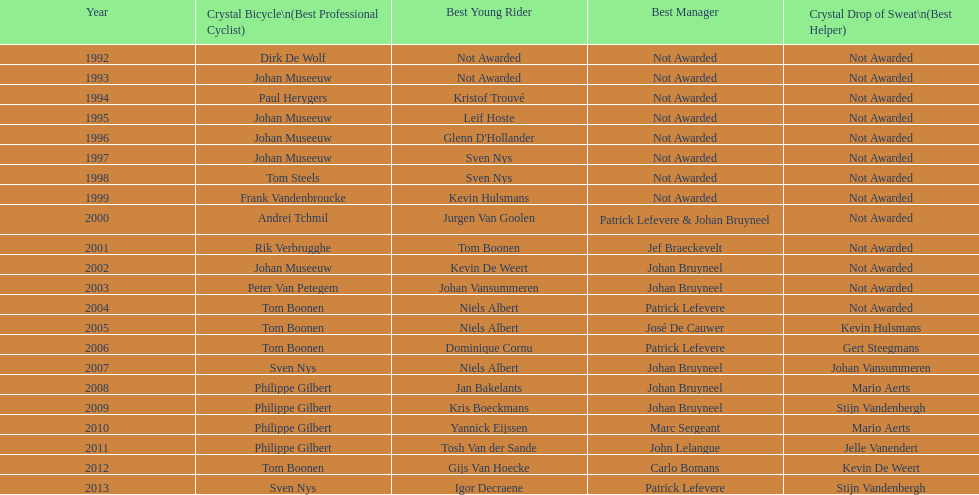What is the total number of times johan bryneel's name appears on all of these lists? 6. 